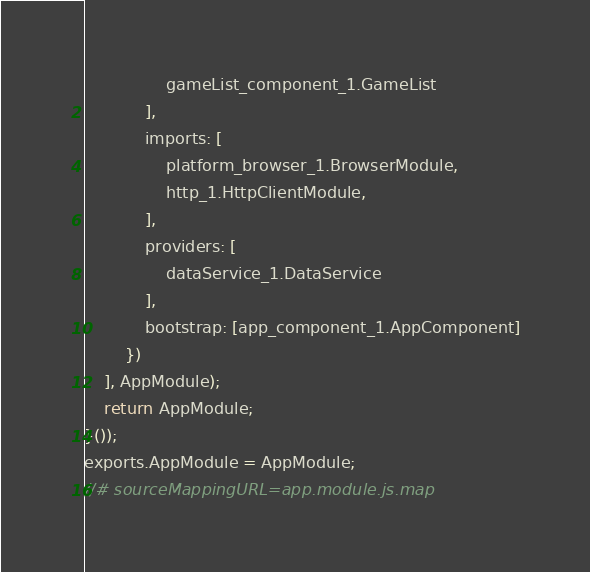<code> <loc_0><loc_0><loc_500><loc_500><_JavaScript_>                gameList_component_1.GameList
            ],
            imports: [
                platform_browser_1.BrowserModule,
                http_1.HttpClientModule,
            ],
            providers: [
                dataService_1.DataService
            ],
            bootstrap: [app_component_1.AppComponent]
        })
    ], AppModule);
    return AppModule;
}());
exports.AppModule = AppModule;
//# sourceMappingURL=app.module.js.map</code> 